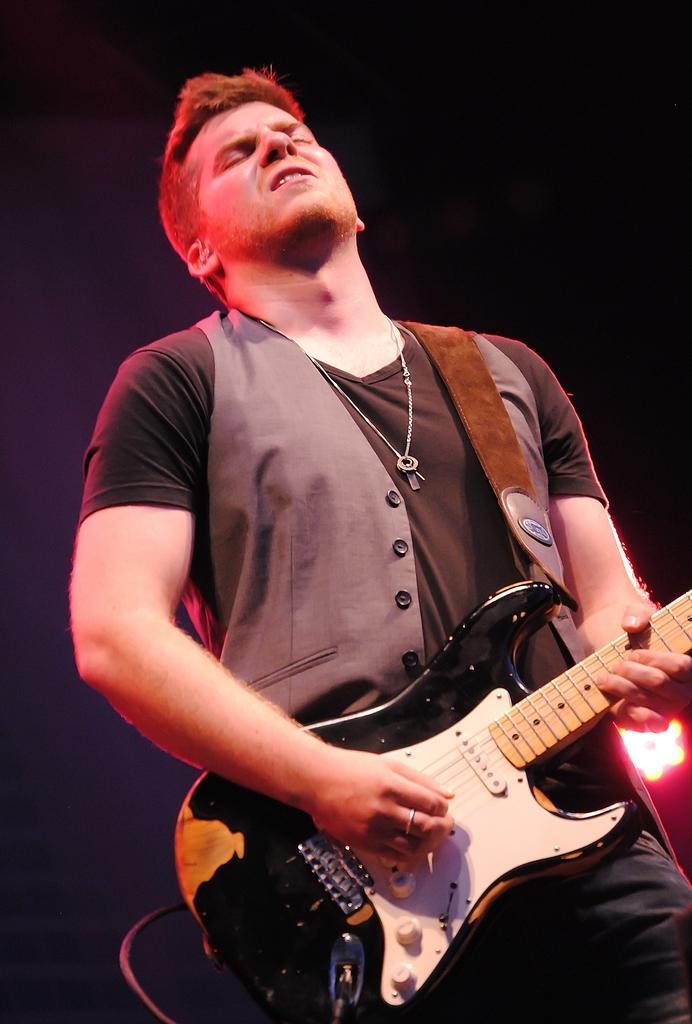Could you give a brief overview of what you see in this image? In the image we can see there is a man who is standing and holding guitar in his hand. 